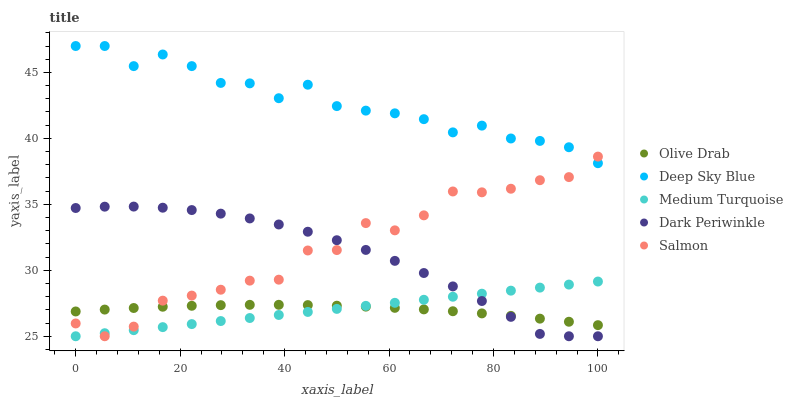Does Olive Drab have the minimum area under the curve?
Answer yes or no. Yes. Does Deep Sky Blue have the maximum area under the curve?
Answer yes or no. Yes. Does Salmon have the minimum area under the curve?
Answer yes or no. No. Does Salmon have the maximum area under the curve?
Answer yes or no. No. Is Medium Turquoise the smoothest?
Answer yes or no. Yes. Is Salmon the roughest?
Answer yes or no. Yes. Is Deep Sky Blue the smoothest?
Answer yes or no. No. Is Deep Sky Blue the roughest?
Answer yes or no. No. Does Medium Turquoise have the lowest value?
Answer yes or no. Yes. Does Deep Sky Blue have the lowest value?
Answer yes or no. No. Does Deep Sky Blue have the highest value?
Answer yes or no. Yes. Does Salmon have the highest value?
Answer yes or no. No. Is Medium Turquoise less than Deep Sky Blue?
Answer yes or no. Yes. Is Deep Sky Blue greater than Olive Drab?
Answer yes or no. Yes. Does Medium Turquoise intersect Salmon?
Answer yes or no. Yes. Is Medium Turquoise less than Salmon?
Answer yes or no. No. Is Medium Turquoise greater than Salmon?
Answer yes or no. No. Does Medium Turquoise intersect Deep Sky Blue?
Answer yes or no. No. 